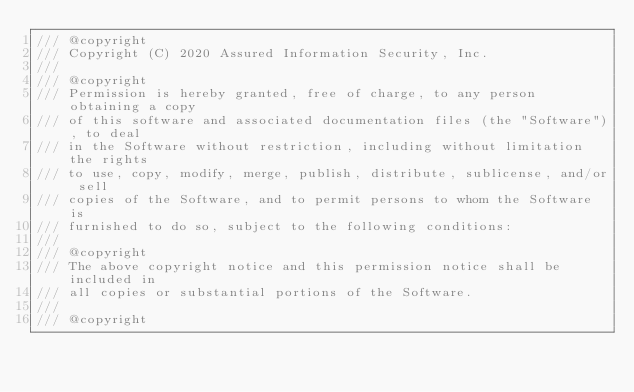Convert code to text. <code><loc_0><loc_0><loc_500><loc_500><_C++_>/// @copyright
/// Copyright (C) 2020 Assured Information Security, Inc.
///
/// @copyright
/// Permission is hereby granted, free of charge, to any person obtaining a copy
/// of this software and associated documentation files (the "Software"), to deal
/// in the Software without restriction, including without limitation the rights
/// to use, copy, modify, merge, publish, distribute, sublicense, and/or sell
/// copies of the Software, and to permit persons to whom the Software is
/// furnished to do so, subject to the following conditions:
///
/// @copyright
/// The above copyright notice and this permission notice shall be included in
/// all copies or substantial portions of the Software.
///
/// @copyright</code> 